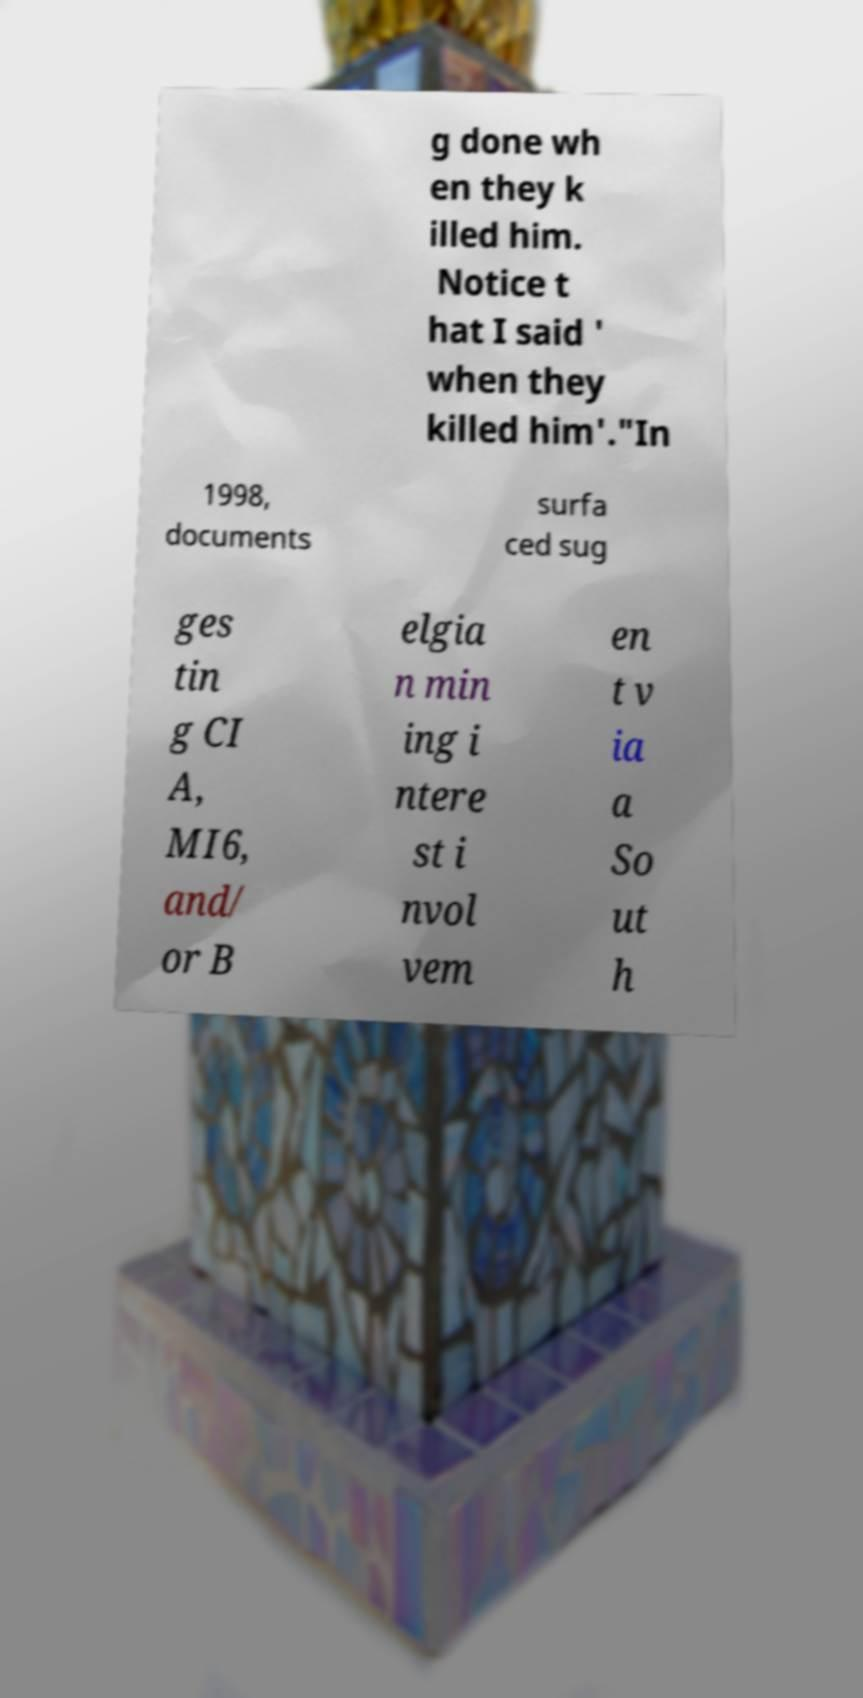Can you read and provide the text displayed in the image?This photo seems to have some interesting text. Can you extract and type it out for me? g done wh en they k illed him. Notice t hat I said ' when they killed him'."In 1998, documents surfa ced sug ges tin g CI A, MI6, and/ or B elgia n min ing i ntere st i nvol vem en t v ia a So ut h 